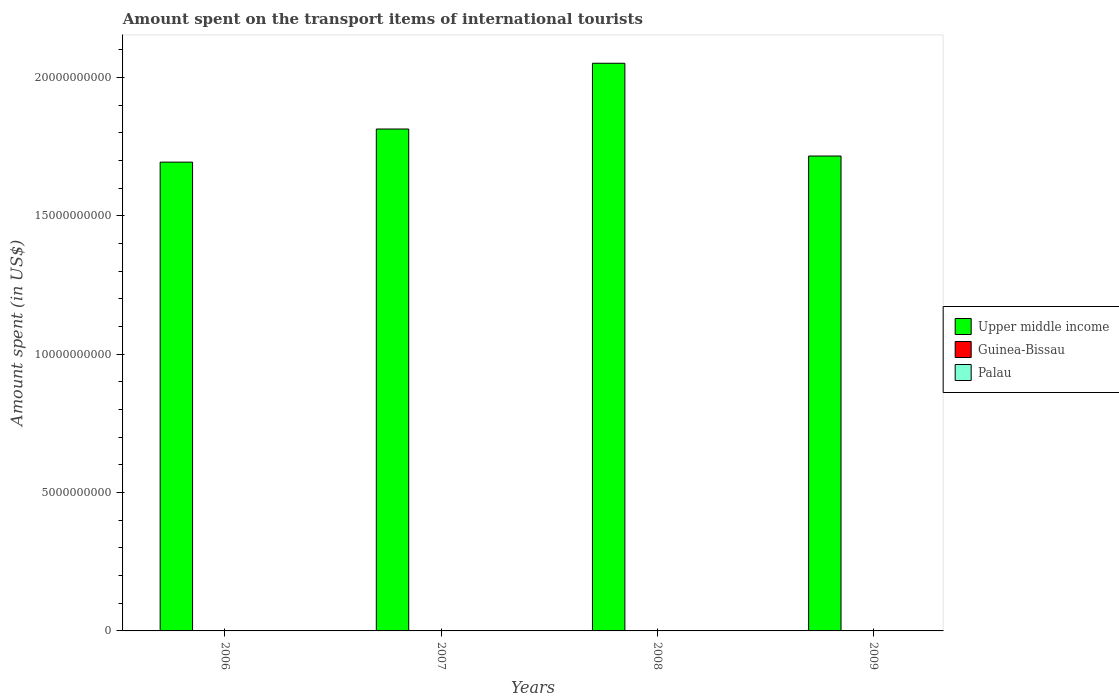How many different coloured bars are there?
Make the answer very short. 3. Are the number of bars on each tick of the X-axis equal?
Your response must be concise. Yes. How many bars are there on the 1st tick from the left?
Your answer should be compact. 3. What is the label of the 2nd group of bars from the left?
Offer a very short reply. 2007. What is the amount spent on the transport items of international tourists in Palau in 2009?
Provide a short and direct response. 9.30e+06. Across all years, what is the maximum amount spent on the transport items of international tourists in Guinea-Bissau?
Your response must be concise. 2.30e+06. Across all years, what is the minimum amount spent on the transport items of international tourists in Guinea-Bissau?
Make the answer very short. 3.00e+05. In which year was the amount spent on the transport items of international tourists in Palau maximum?
Your answer should be very brief. 2008. What is the total amount spent on the transport items of international tourists in Guinea-Bissau in the graph?
Offer a terse response. 3.60e+06. What is the difference between the amount spent on the transport items of international tourists in Palau in 2006 and that in 2009?
Keep it short and to the point. -3.00e+05. What is the difference between the amount spent on the transport items of international tourists in Guinea-Bissau in 2007 and the amount spent on the transport items of international tourists in Palau in 2006?
Your response must be concise. -8.50e+06. What is the average amount spent on the transport items of international tourists in Guinea-Bissau per year?
Keep it short and to the point. 9.00e+05. In the year 2007, what is the difference between the amount spent on the transport items of international tourists in Upper middle income and amount spent on the transport items of international tourists in Palau?
Provide a short and direct response. 1.81e+1. What is the ratio of the amount spent on the transport items of international tourists in Palau in 2007 to that in 2008?
Offer a terse response. 0.78. Is the difference between the amount spent on the transport items of international tourists in Upper middle income in 2007 and 2009 greater than the difference between the amount spent on the transport items of international tourists in Palau in 2007 and 2009?
Make the answer very short. Yes. What is the difference between the highest and the second highest amount spent on the transport items of international tourists in Guinea-Bissau?
Provide a succinct answer. 1.80e+06. What is the difference between the highest and the lowest amount spent on the transport items of international tourists in Upper middle income?
Make the answer very short. 3.57e+09. What does the 2nd bar from the left in 2009 represents?
Provide a succinct answer. Guinea-Bissau. What does the 3rd bar from the right in 2009 represents?
Offer a terse response. Upper middle income. How many bars are there?
Provide a succinct answer. 12. Are all the bars in the graph horizontal?
Provide a short and direct response. No. Does the graph contain any zero values?
Your answer should be very brief. No. How many legend labels are there?
Offer a very short reply. 3. How are the legend labels stacked?
Your response must be concise. Vertical. What is the title of the graph?
Your answer should be compact. Amount spent on the transport items of international tourists. What is the label or title of the Y-axis?
Your response must be concise. Amount spent (in US$). What is the Amount spent (in US$) in Upper middle income in 2006?
Give a very brief answer. 1.69e+1. What is the Amount spent (in US$) in Guinea-Bissau in 2006?
Offer a terse response. 2.30e+06. What is the Amount spent (in US$) in Palau in 2006?
Your answer should be very brief. 9.00e+06. What is the Amount spent (in US$) in Upper middle income in 2007?
Keep it short and to the point. 1.81e+1. What is the Amount spent (in US$) in Guinea-Bissau in 2007?
Your answer should be compact. 5.00e+05. What is the Amount spent (in US$) in Palau in 2007?
Your response must be concise. 8.30e+06. What is the Amount spent (in US$) in Upper middle income in 2008?
Provide a short and direct response. 2.05e+1. What is the Amount spent (in US$) of Palau in 2008?
Offer a very short reply. 1.06e+07. What is the Amount spent (in US$) in Upper middle income in 2009?
Ensure brevity in your answer.  1.72e+1. What is the Amount spent (in US$) of Palau in 2009?
Your response must be concise. 9.30e+06. Across all years, what is the maximum Amount spent (in US$) in Upper middle income?
Keep it short and to the point. 2.05e+1. Across all years, what is the maximum Amount spent (in US$) of Guinea-Bissau?
Make the answer very short. 2.30e+06. Across all years, what is the maximum Amount spent (in US$) of Palau?
Keep it short and to the point. 1.06e+07. Across all years, what is the minimum Amount spent (in US$) in Upper middle income?
Provide a succinct answer. 1.69e+1. Across all years, what is the minimum Amount spent (in US$) in Guinea-Bissau?
Provide a short and direct response. 3.00e+05. Across all years, what is the minimum Amount spent (in US$) of Palau?
Offer a terse response. 8.30e+06. What is the total Amount spent (in US$) in Upper middle income in the graph?
Ensure brevity in your answer.  7.28e+1. What is the total Amount spent (in US$) in Guinea-Bissau in the graph?
Your answer should be compact. 3.60e+06. What is the total Amount spent (in US$) of Palau in the graph?
Provide a succinct answer. 3.72e+07. What is the difference between the Amount spent (in US$) in Upper middle income in 2006 and that in 2007?
Provide a succinct answer. -1.20e+09. What is the difference between the Amount spent (in US$) of Guinea-Bissau in 2006 and that in 2007?
Make the answer very short. 1.80e+06. What is the difference between the Amount spent (in US$) of Upper middle income in 2006 and that in 2008?
Offer a very short reply. -3.57e+09. What is the difference between the Amount spent (in US$) in Guinea-Bissau in 2006 and that in 2008?
Your response must be concise. 1.80e+06. What is the difference between the Amount spent (in US$) in Palau in 2006 and that in 2008?
Keep it short and to the point. -1.60e+06. What is the difference between the Amount spent (in US$) in Upper middle income in 2006 and that in 2009?
Your response must be concise. -2.21e+08. What is the difference between the Amount spent (in US$) of Upper middle income in 2007 and that in 2008?
Your answer should be compact. -2.38e+09. What is the difference between the Amount spent (in US$) of Guinea-Bissau in 2007 and that in 2008?
Provide a succinct answer. 0. What is the difference between the Amount spent (in US$) of Palau in 2007 and that in 2008?
Your response must be concise. -2.30e+06. What is the difference between the Amount spent (in US$) in Upper middle income in 2007 and that in 2009?
Provide a short and direct response. 9.76e+08. What is the difference between the Amount spent (in US$) of Guinea-Bissau in 2007 and that in 2009?
Give a very brief answer. 2.00e+05. What is the difference between the Amount spent (in US$) of Upper middle income in 2008 and that in 2009?
Offer a very short reply. 3.35e+09. What is the difference between the Amount spent (in US$) in Guinea-Bissau in 2008 and that in 2009?
Make the answer very short. 2.00e+05. What is the difference between the Amount spent (in US$) in Palau in 2008 and that in 2009?
Provide a short and direct response. 1.30e+06. What is the difference between the Amount spent (in US$) of Upper middle income in 2006 and the Amount spent (in US$) of Guinea-Bissau in 2007?
Your answer should be very brief. 1.69e+1. What is the difference between the Amount spent (in US$) in Upper middle income in 2006 and the Amount spent (in US$) in Palau in 2007?
Your response must be concise. 1.69e+1. What is the difference between the Amount spent (in US$) of Guinea-Bissau in 2006 and the Amount spent (in US$) of Palau in 2007?
Make the answer very short. -6.00e+06. What is the difference between the Amount spent (in US$) in Upper middle income in 2006 and the Amount spent (in US$) in Guinea-Bissau in 2008?
Offer a very short reply. 1.69e+1. What is the difference between the Amount spent (in US$) of Upper middle income in 2006 and the Amount spent (in US$) of Palau in 2008?
Ensure brevity in your answer.  1.69e+1. What is the difference between the Amount spent (in US$) of Guinea-Bissau in 2006 and the Amount spent (in US$) of Palau in 2008?
Your response must be concise. -8.30e+06. What is the difference between the Amount spent (in US$) in Upper middle income in 2006 and the Amount spent (in US$) in Guinea-Bissau in 2009?
Your answer should be very brief. 1.69e+1. What is the difference between the Amount spent (in US$) in Upper middle income in 2006 and the Amount spent (in US$) in Palau in 2009?
Your answer should be compact. 1.69e+1. What is the difference between the Amount spent (in US$) of Guinea-Bissau in 2006 and the Amount spent (in US$) of Palau in 2009?
Offer a very short reply. -7.00e+06. What is the difference between the Amount spent (in US$) of Upper middle income in 2007 and the Amount spent (in US$) of Guinea-Bissau in 2008?
Offer a very short reply. 1.81e+1. What is the difference between the Amount spent (in US$) of Upper middle income in 2007 and the Amount spent (in US$) of Palau in 2008?
Ensure brevity in your answer.  1.81e+1. What is the difference between the Amount spent (in US$) in Guinea-Bissau in 2007 and the Amount spent (in US$) in Palau in 2008?
Give a very brief answer. -1.01e+07. What is the difference between the Amount spent (in US$) in Upper middle income in 2007 and the Amount spent (in US$) in Guinea-Bissau in 2009?
Ensure brevity in your answer.  1.81e+1. What is the difference between the Amount spent (in US$) in Upper middle income in 2007 and the Amount spent (in US$) in Palau in 2009?
Your response must be concise. 1.81e+1. What is the difference between the Amount spent (in US$) of Guinea-Bissau in 2007 and the Amount spent (in US$) of Palau in 2009?
Your response must be concise. -8.80e+06. What is the difference between the Amount spent (in US$) in Upper middle income in 2008 and the Amount spent (in US$) in Guinea-Bissau in 2009?
Provide a short and direct response. 2.05e+1. What is the difference between the Amount spent (in US$) of Upper middle income in 2008 and the Amount spent (in US$) of Palau in 2009?
Make the answer very short. 2.05e+1. What is the difference between the Amount spent (in US$) in Guinea-Bissau in 2008 and the Amount spent (in US$) in Palau in 2009?
Make the answer very short. -8.80e+06. What is the average Amount spent (in US$) of Upper middle income per year?
Your response must be concise. 1.82e+1. What is the average Amount spent (in US$) in Guinea-Bissau per year?
Give a very brief answer. 9.00e+05. What is the average Amount spent (in US$) in Palau per year?
Your answer should be compact. 9.30e+06. In the year 2006, what is the difference between the Amount spent (in US$) of Upper middle income and Amount spent (in US$) of Guinea-Bissau?
Offer a terse response. 1.69e+1. In the year 2006, what is the difference between the Amount spent (in US$) of Upper middle income and Amount spent (in US$) of Palau?
Your answer should be compact. 1.69e+1. In the year 2006, what is the difference between the Amount spent (in US$) in Guinea-Bissau and Amount spent (in US$) in Palau?
Your response must be concise. -6.70e+06. In the year 2007, what is the difference between the Amount spent (in US$) of Upper middle income and Amount spent (in US$) of Guinea-Bissau?
Your answer should be compact. 1.81e+1. In the year 2007, what is the difference between the Amount spent (in US$) of Upper middle income and Amount spent (in US$) of Palau?
Make the answer very short. 1.81e+1. In the year 2007, what is the difference between the Amount spent (in US$) of Guinea-Bissau and Amount spent (in US$) of Palau?
Your answer should be compact. -7.80e+06. In the year 2008, what is the difference between the Amount spent (in US$) of Upper middle income and Amount spent (in US$) of Guinea-Bissau?
Offer a terse response. 2.05e+1. In the year 2008, what is the difference between the Amount spent (in US$) in Upper middle income and Amount spent (in US$) in Palau?
Keep it short and to the point. 2.05e+1. In the year 2008, what is the difference between the Amount spent (in US$) of Guinea-Bissau and Amount spent (in US$) of Palau?
Keep it short and to the point. -1.01e+07. In the year 2009, what is the difference between the Amount spent (in US$) of Upper middle income and Amount spent (in US$) of Guinea-Bissau?
Ensure brevity in your answer.  1.72e+1. In the year 2009, what is the difference between the Amount spent (in US$) in Upper middle income and Amount spent (in US$) in Palau?
Your answer should be very brief. 1.72e+1. In the year 2009, what is the difference between the Amount spent (in US$) of Guinea-Bissau and Amount spent (in US$) of Palau?
Ensure brevity in your answer.  -9.00e+06. What is the ratio of the Amount spent (in US$) in Upper middle income in 2006 to that in 2007?
Your answer should be compact. 0.93. What is the ratio of the Amount spent (in US$) in Palau in 2006 to that in 2007?
Your answer should be compact. 1.08. What is the ratio of the Amount spent (in US$) of Upper middle income in 2006 to that in 2008?
Offer a terse response. 0.83. What is the ratio of the Amount spent (in US$) in Guinea-Bissau in 2006 to that in 2008?
Give a very brief answer. 4.6. What is the ratio of the Amount spent (in US$) of Palau in 2006 to that in 2008?
Keep it short and to the point. 0.85. What is the ratio of the Amount spent (in US$) in Upper middle income in 2006 to that in 2009?
Make the answer very short. 0.99. What is the ratio of the Amount spent (in US$) of Guinea-Bissau in 2006 to that in 2009?
Offer a very short reply. 7.67. What is the ratio of the Amount spent (in US$) of Upper middle income in 2007 to that in 2008?
Offer a very short reply. 0.88. What is the ratio of the Amount spent (in US$) of Guinea-Bissau in 2007 to that in 2008?
Ensure brevity in your answer.  1. What is the ratio of the Amount spent (in US$) in Palau in 2007 to that in 2008?
Give a very brief answer. 0.78. What is the ratio of the Amount spent (in US$) in Upper middle income in 2007 to that in 2009?
Make the answer very short. 1.06. What is the ratio of the Amount spent (in US$) in Palau in 2007 to that in 2009?
Your response must be concise. 0.89. What is the ratio of the Amount spent (in US$) in Upper middle income in 2008 to that in 2009?
Keep it short and to the point. 1.2. What is the ratio of the Amount spent (in US$) of Guinea-Bissau in 2008 to that in 2009?
Make the answer very short. 1.67. What is the ratio of the Amount spent (in US$) in Palau in 2008 to that in 2009?
Keep it short and to the point. 1.14. What is the difference between the highest and the second highest Amount spent (in US$) in Upper middle income?
Your response must be concise. 2.38e+09. What is the difference between the highest and the second highest Amount spent (in US$) in Guinea-Bissau?
Offer a very short reply. 1.80e+06. What is the difference between the highest and the second highest Amount spent (in US$) of Palau?
Ensure brevity in your answer.  1.30e+06. What is the difference between the highest and the lowest Amount spent (in US$) in Upper middle income?
Your answer should be compact. 3.57e+09. What is the difference between the highest and the lowest Amount spent (in US$) of Palau?
Make the answer very short. 2.30e+06. 